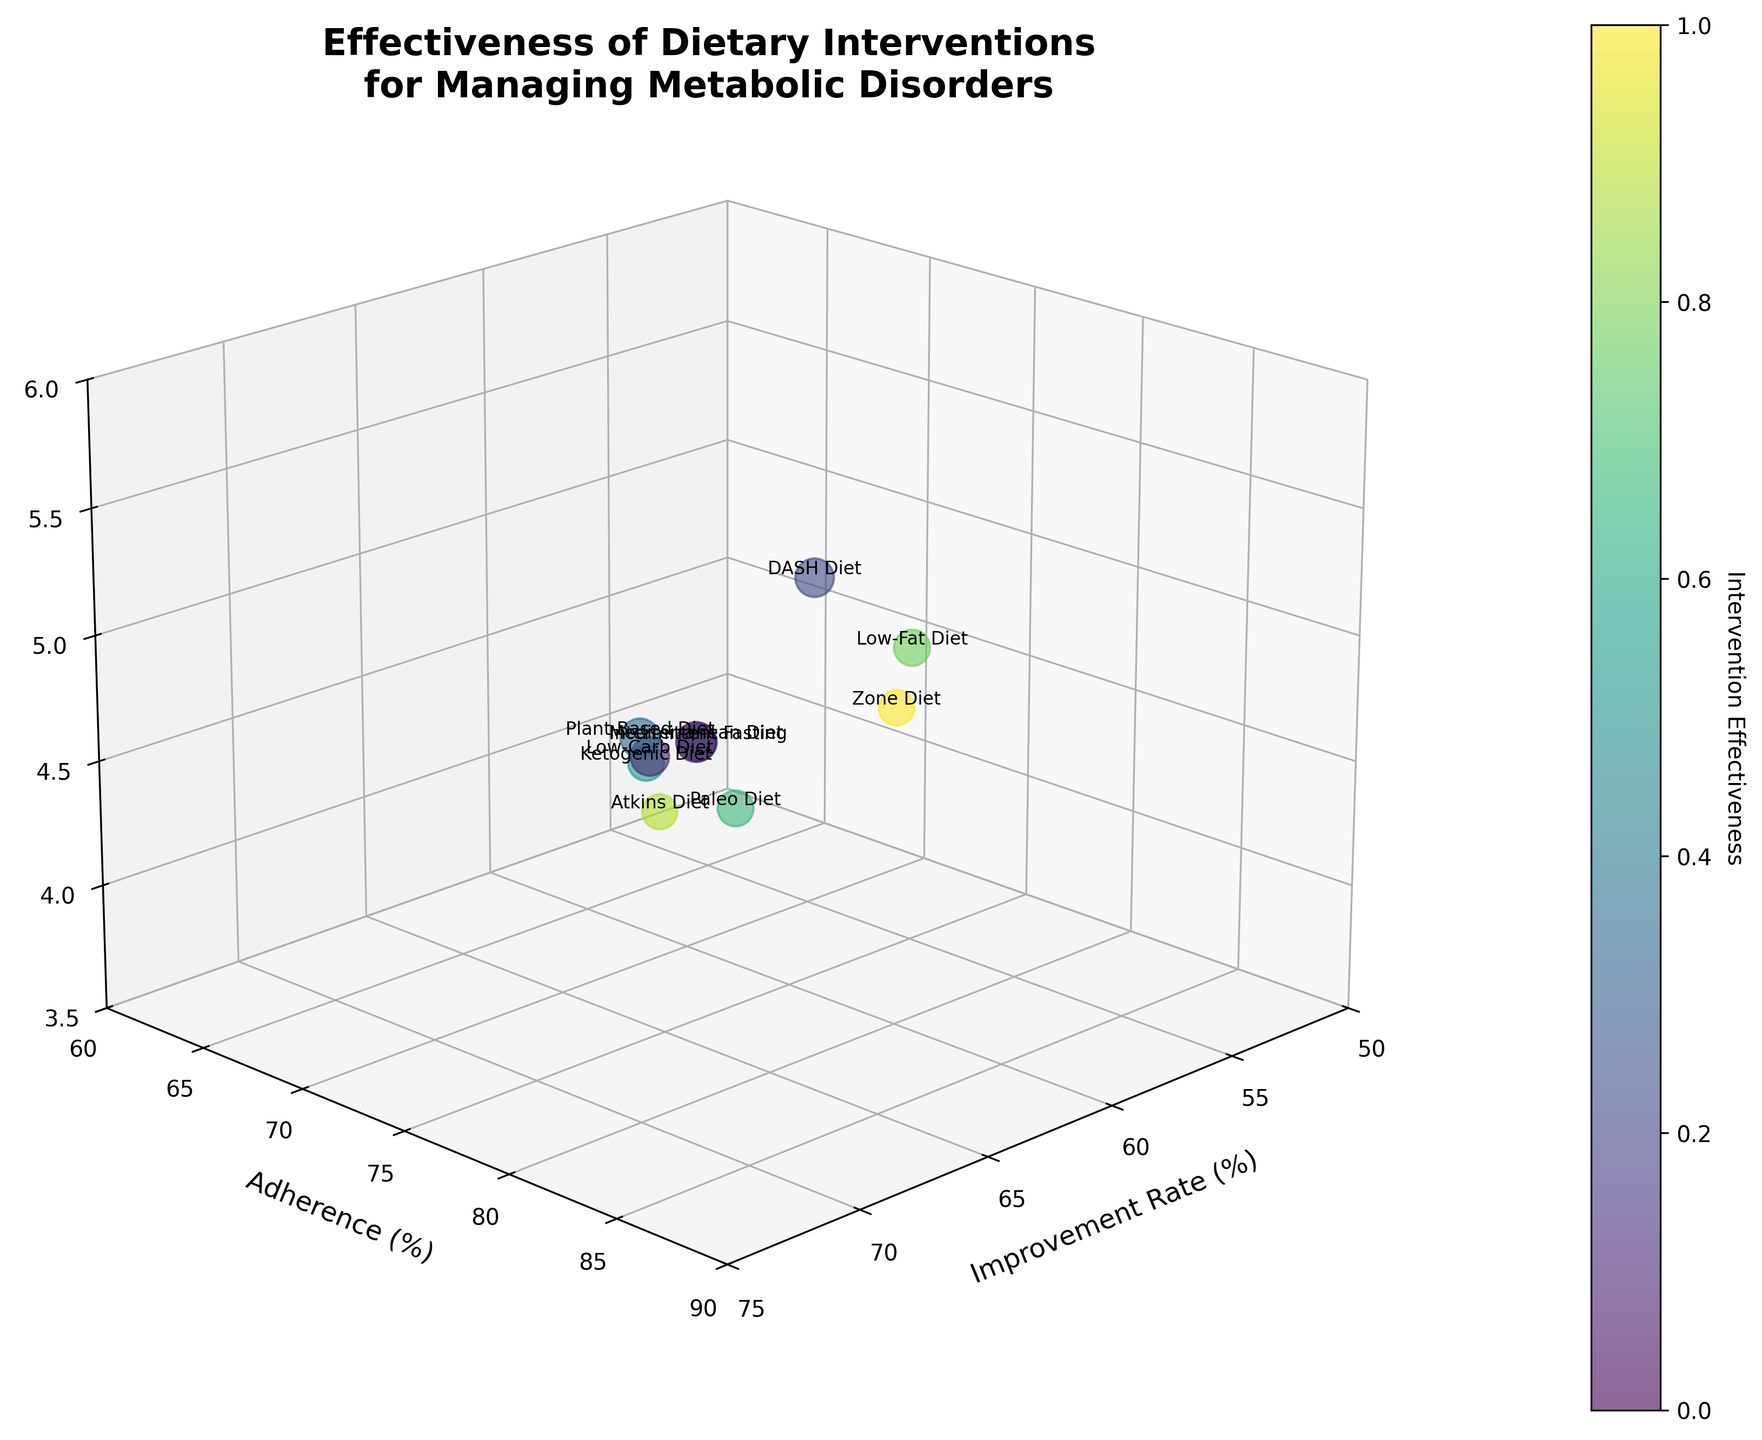What's the title of the chart? The title is usually placed at the top of the chart and is used to describe what the chart is all about.
Answer: Effectiveness of Dietary Interventions for Managing Metabolic Disorders Which diet has the highest adherence rate? Look for the data point that has the highest y-axis value which corresponds to adherence (%)
Answer: Mediterranean Diet What's the improvement rate for the DASH Diet? Find the corresponding bubble labeled as "DASH Diet" and check its x-axis value which indicates the improvement rate (%)
Answer: 65% How does the long-term outcome of the Ketogenic Diet compare to the Mediterranean Diet? Identify the z-axis values for both the Ketogenic Diet and the Mediterranean Diet and compare them. The Mediterranean Diet has 5.2 years while the Ketogenic Diet has 4.2 years.
Answer: The Mediterranean Diet has better long-term outcomes Which diet has an improvement rate greater than 60% but less than 65%? Filter the data points based on the x-axis range of 60% to 65% and identify the corresponding diet. The DASH Diet has an improvement rate of 65%.
Answer: DASH Diet What's the size relationship between bubbles for Mediterranean Diet and Low-Fat Diet? The size of the bubbles is determined by (Improvement Rate + Adherence) * 2. Calculate it for both diets and compare. For Mediterranean (72 + 85)*2 = 314, for Low-Fat (55 + 75)*2 = 260.
Answer: Mediterranean Diet bubble is larger How many dietary interventions are plotted in the chart? Count the number of bubbles labeled with different diet interventions. The data includes 10 interventions.
Answer: 10 Which diet has the smallest bubble, symbolizing the least overall effectiveness? The smallest bubble represents the lowest sum of improvement rate and adherence rates. Given this, sum the rates and identify the lowest. Atkins Diet: (57 + 65) * 2 = 244.
Answer: Atkins Diet What is the adherence rate for diets with improvement rates above 70%? Filter the bubbles with x-axis values above 70% and identify the y-axis (adherence) values for those bubbles. Both the Mediterranean Diet (85%) and Plant-Based Diet (80%).
Answer: 85% and 80% Which diet has the longest long-term outcomes? Look at the maximum z-axis value and identify the corresponding diet. DASH Diet has a long-term outcome of 5.5 years.
Answer: DASH Diet 